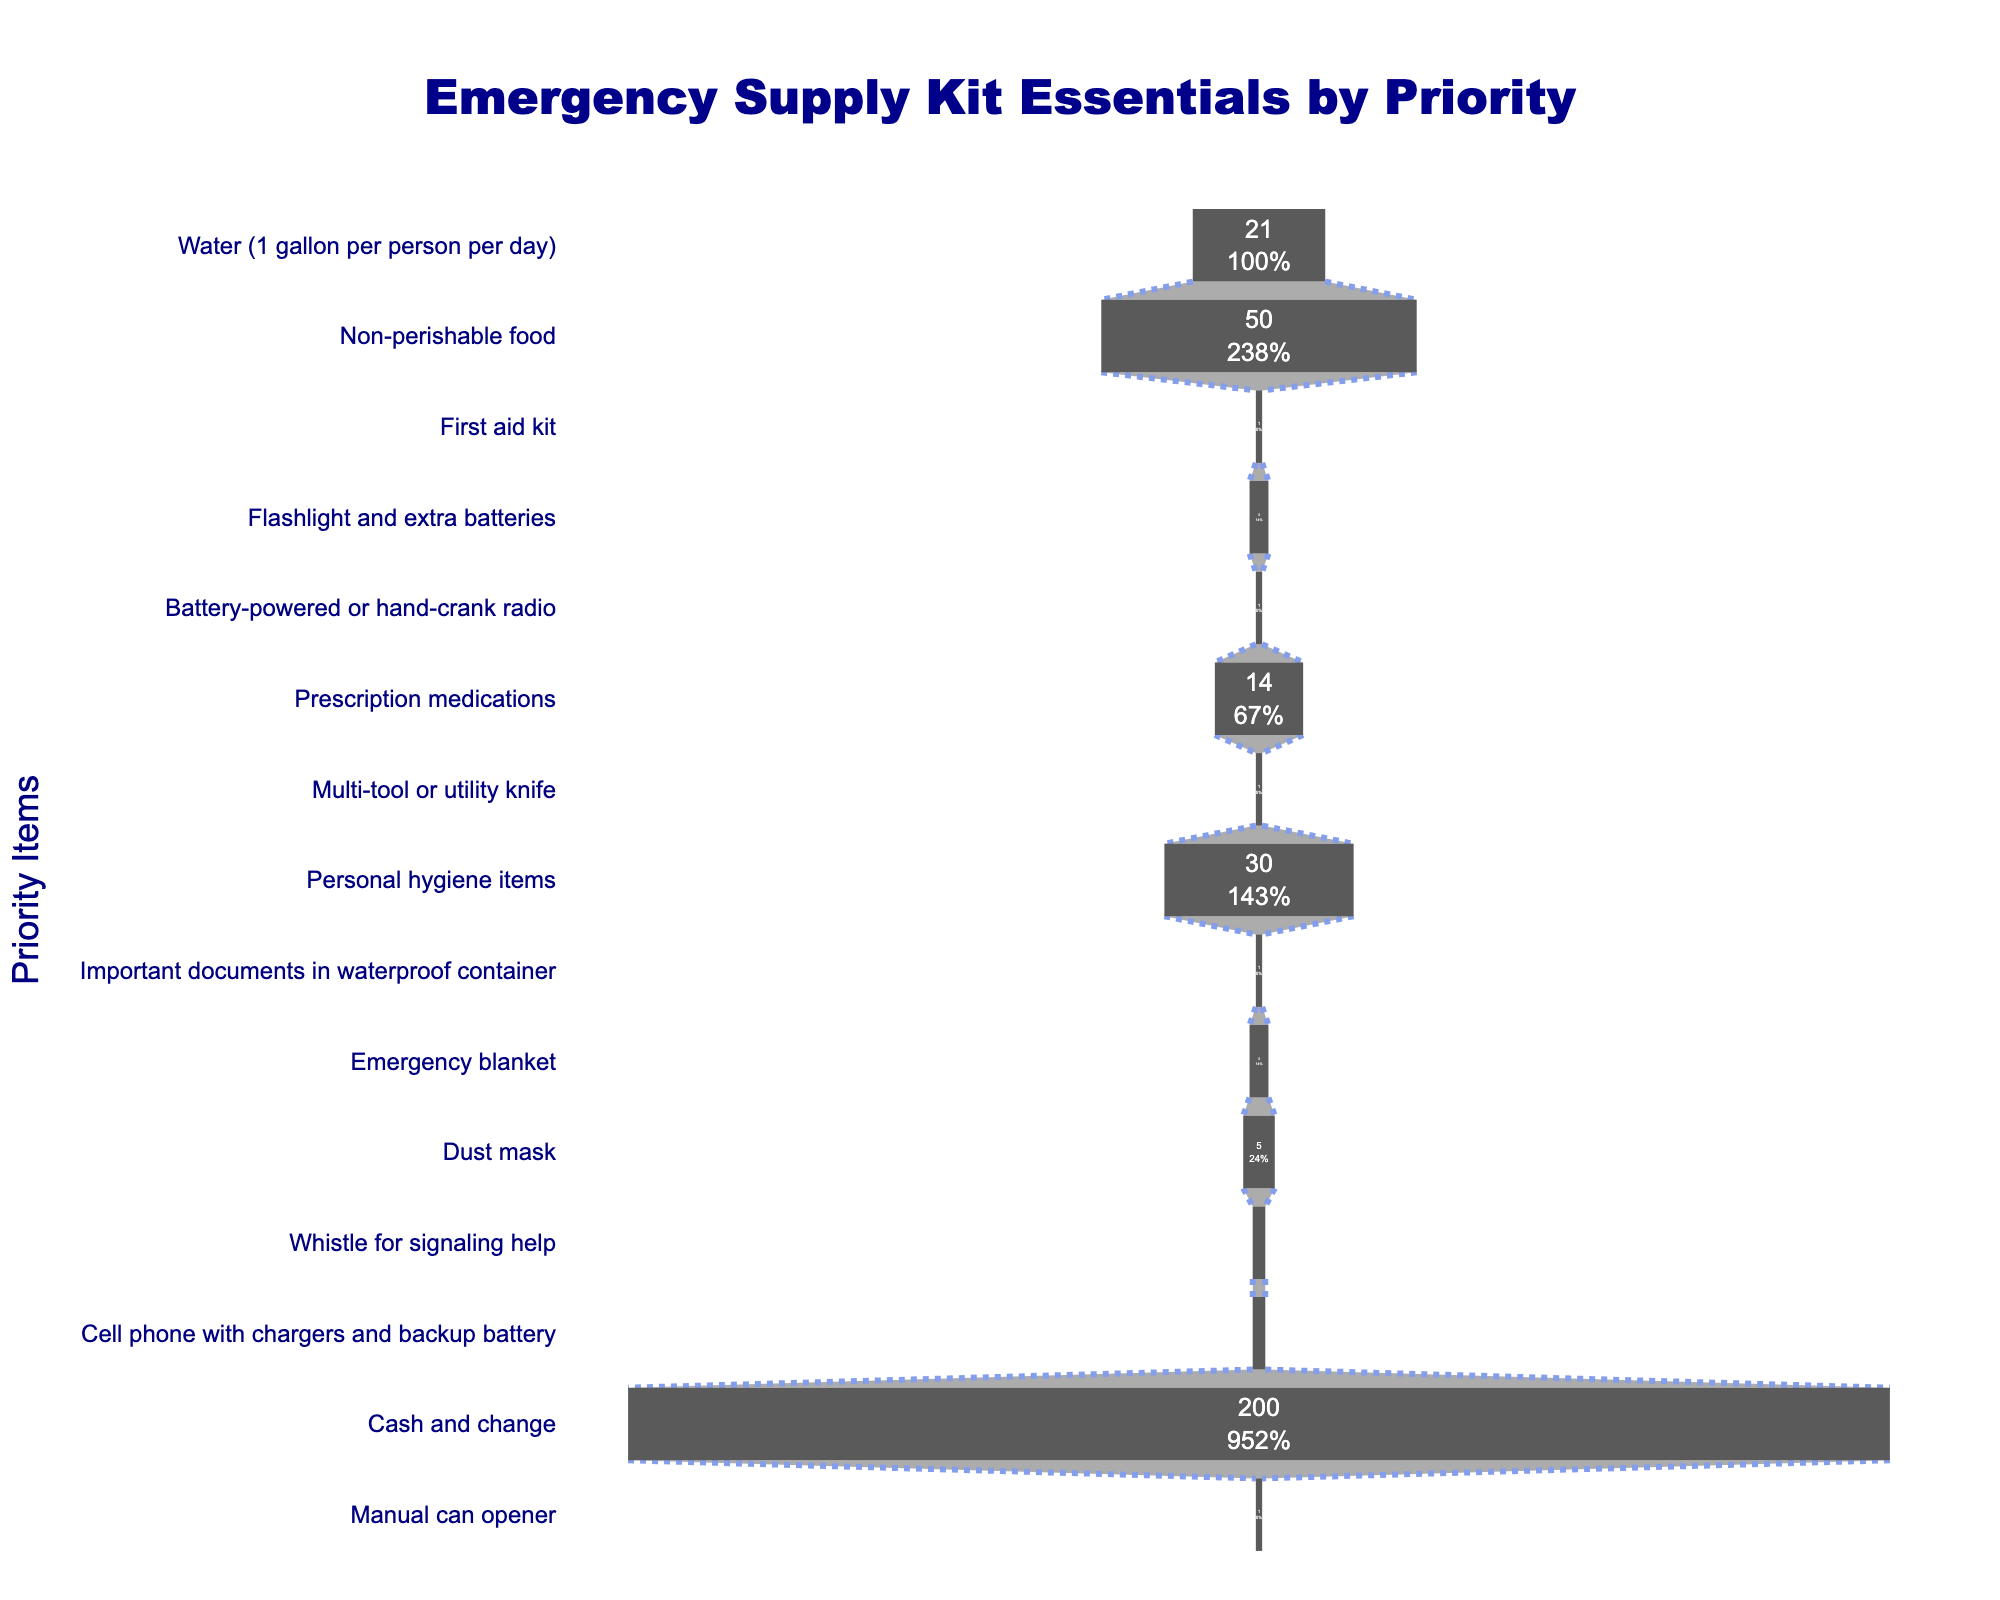How many items are included in the emergency supply kit? The funnel chart shows each item list along the y-axis. By counting each item, we find there are 15.
Answer: 15 What's the most prioritized item, and how many units are recommended for it? At the top of the funnel chart, the highest priority item is listed, which is "Water (1 gallon per person per day)" with 21 units recommended.
Answer: Water (1 gallon per person per day), 21 units What percentage of the initial quantity does the most prioritized item (water) represent? The funnel chart shows percentages for each item. The "Water (1 gallon per person per day)" is the first item, and it occupies 100% since it is the baseline for percentage calculations.
Answer: 100% Which item takes up the smallest quantity, and what is the quantity? By observing the sizes of the sections in the funnel chart, the smallest sections are for items where only 1 unit is required. These items include "First aid kit," "Battery-powered or hand-crank radio," "Multi-tool or utility knife," "Important documents in waterproof container," and "Manual can opener."
Answer: First aid kit, Battery-powered or hand-crank radio, Multi-tool or utility knife, Important documents in waterproof container, Manual can opener; each with 1 unit How many items require more than 10 units? Items needing more than 10 units can be identified by checking the x-axis values. "Water (1 gallon per person per day)," "Non-perishable food," "Prescription medications," and "Personal hygiene items" fit this criterion.
Answer: 4 items Which item accounts for the second-highest percentage after water? Observing the percentages next to each segment of the funnel chart, "Non-perishable food" is the second item after "Water," and its percentage is displayed in its segment.
Answer: Non-perishable food How many items require the same quantity as the lowest quantity item? First, find out that the lowest quantity is 1 unit. Then, count the items with this quantity: "First aid kit," "Battery-powered or hand-crank radio," "Multi-tool or utility knife," "Important documents in waterproof container," and "Manual can opener."
Answer: 5 items What is the cumulative total for items that require exactly 3 units? There are two items with 3 units which are "Flashlight and extra batteries" and "Emergency blanket". Adding these two together: 3 + 3 = 6.
Answer: 6 What is the sum of the quantities for the top three priority items? Top three priority items are "Water," "Non-perishable food," and "First aid kit" with quantities 21, 50, and 1 respectively. Summing them: 21 + 50 + 1 = 72.
Answer: 72 Which item requires more units: personal hygiene items or prescription medications, and by how many units? "Personal hygiene items" require 30 units, while "Prescription medications" needs 14 units. Subtracting 14 from 30 gives the difference: 30 - 14 = 16 units.
Answer: Personal hygiene items by 16 units 